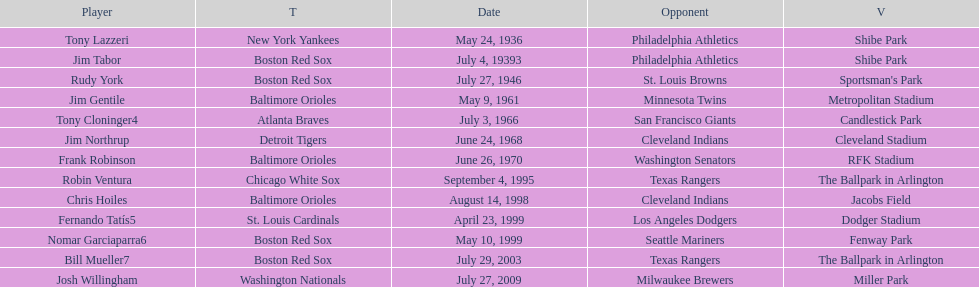Who is the first major league hitter to hit two grand slams in one game? Tony Lazzeri. 